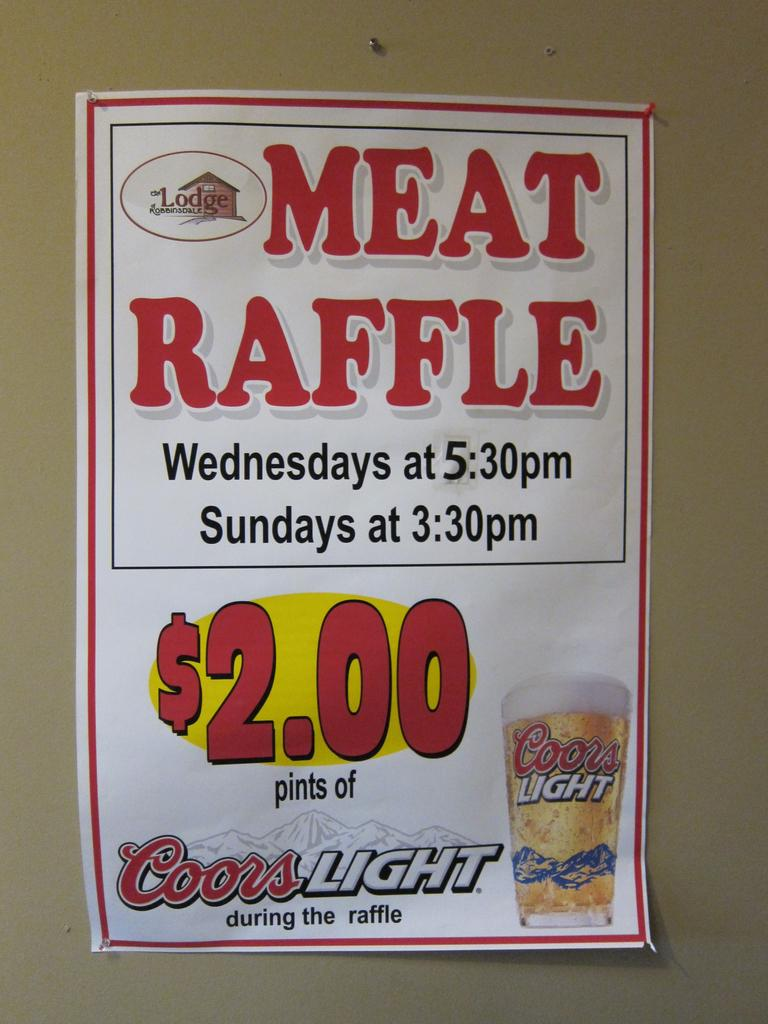What is featured on the poster in the image? There is a poster with text in the image. Does the poster have any specific design elements? Yes, the poster has a logo. What else can be seen in the image besides the poster? There is a glass with a drink in the image. Where is the glass placed in the image? The glass is placed on a wall. What type of scent can be detected from the poster in the image? There is no scent associated with the poster in the image. How does the heat affect the poster in the image? There is no indication of heat affecting the poster in the image. 